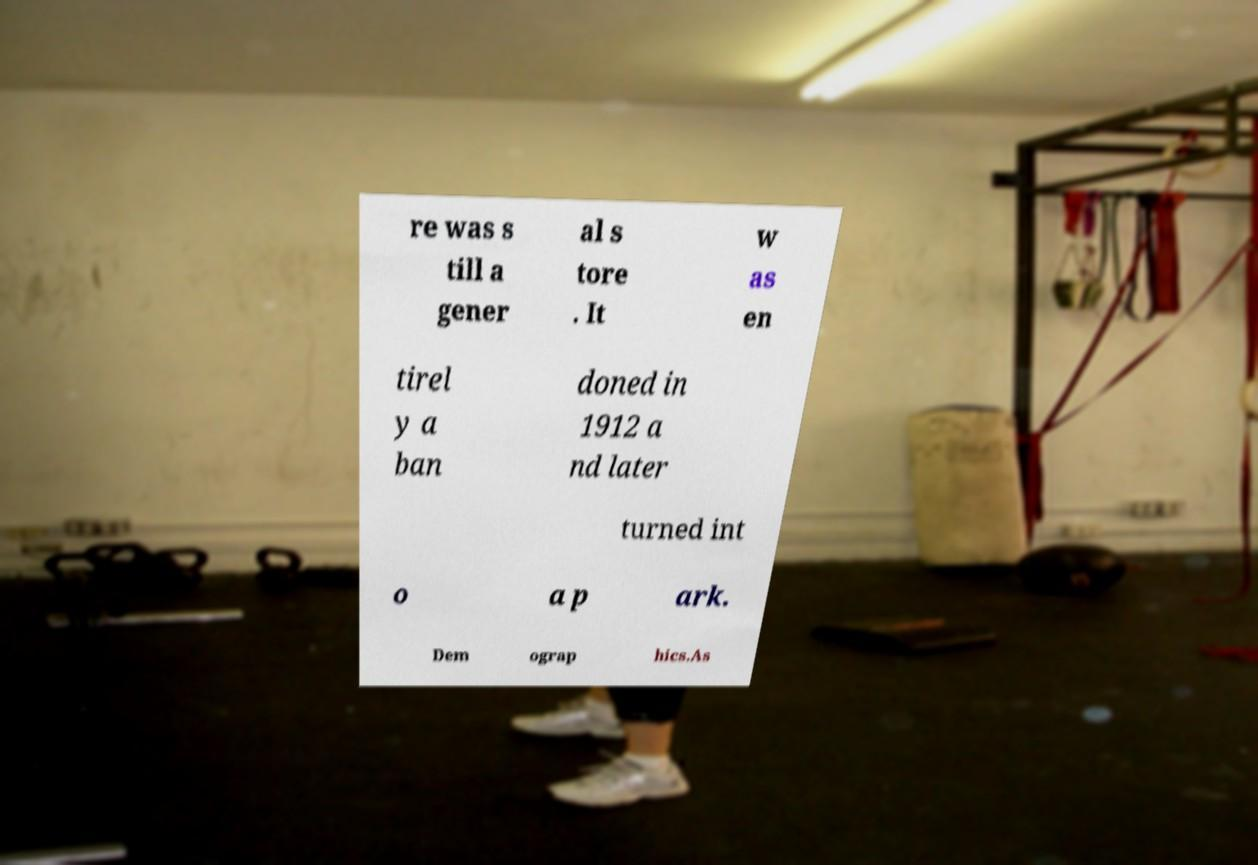Could you extract and type out the text from this image? re was s till a gener al s tore . It w as en tirel y a ban doned in 1912 a nd later turned int o a p ark. Dem ograp hics.As 